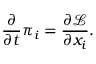<formula> <loc_0><loc_0><loc_500><loc_500>{ \frac { \partial } { \partial t } } \pi _ { i } = { \frac { \partial { \mathcal { L } } } { \partial x _ { i } } } .</formula> 